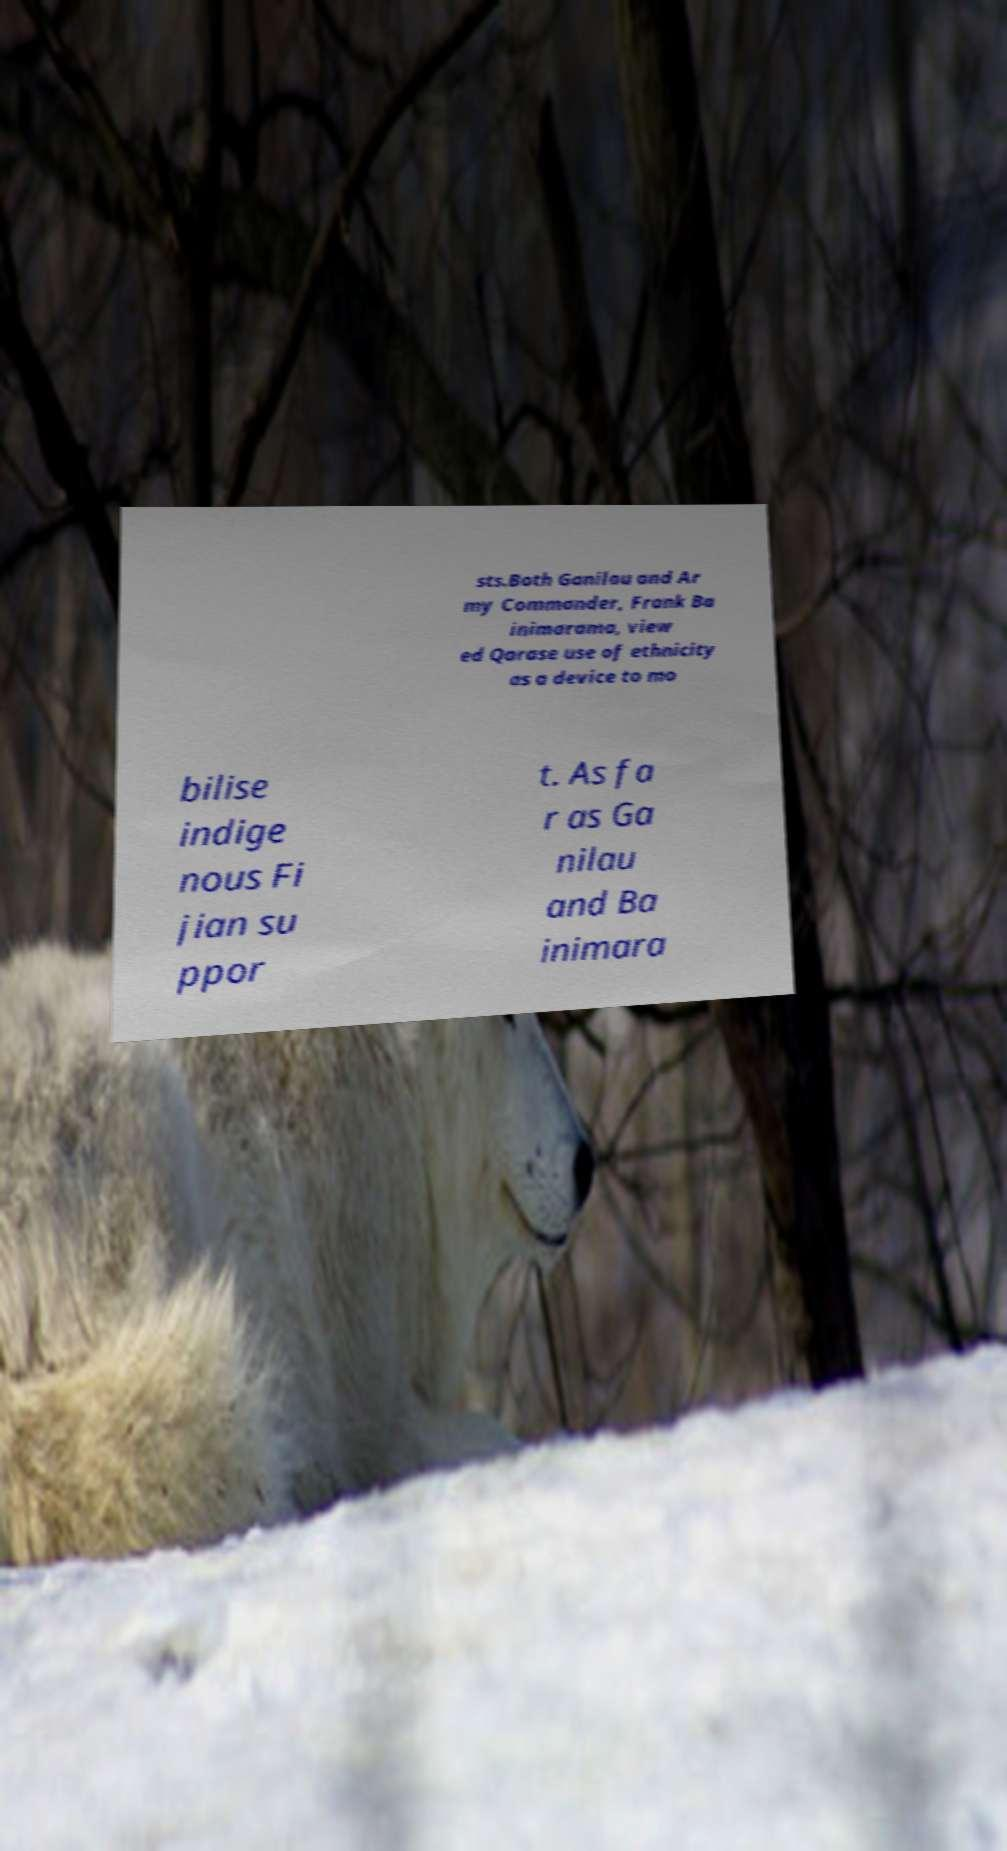Could you assist in decoding the text presented in this image and type it out clearly? sts.Both Ganilau and Ar my Commander, Frank Ba inimarama, view ed Qarase use of ethnicity as a device to mo bilise indige nous Fi jian su ppor t. As fa r as Ga nilau and Ba inimara 